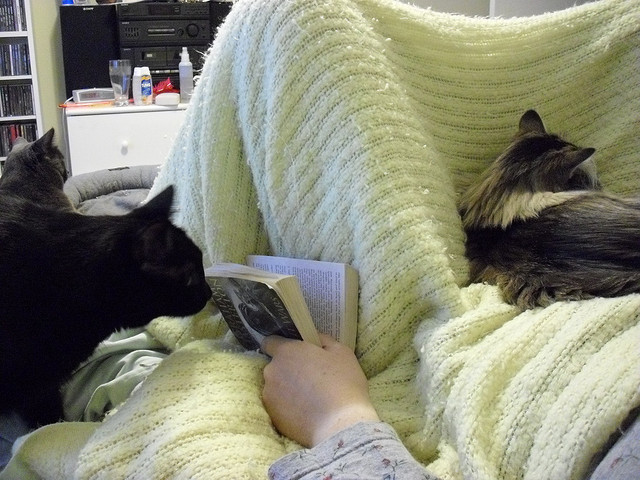What might the person be reading, and do the cats seem interested in the book? Although the specific content of the book is not discernible from the image, the person seems to be enjoying a quiet reading session. The black cat, with its gaze fixed on the book, does seem quite intrigued by it, perhaps enamored by the movement of the pages or simply the proximity to its reading companion. Do the cats typically join the person like this often? Cats are known for enjoying the warmth and companionship of their humans. It's very likely that these cats regularly seek out the cozy embrace of the blanket and the reassuring presence of their human, especially during such serene moments. 